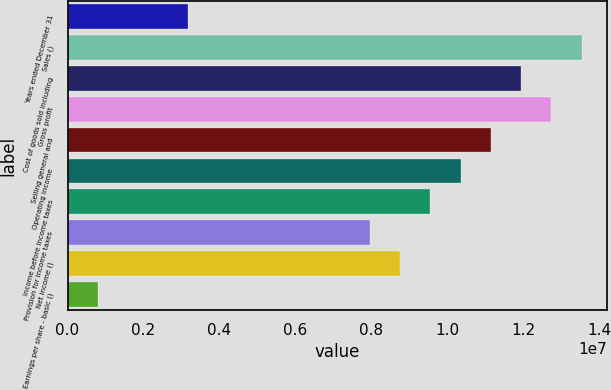Convert chart to OTSL. <chart><loc_0><loc_0><loc_500><loc_500><bar_chart><fcel>Years ended December 31<fcel>Sales ()<fcel>Cost of goods sold including<fcel>Gross profit<fcel>Selling general and<fcel>Operating income<fcel>Income before income taxes<fcel>Provision for income taxes<fcel>Net income ()<fcel>Earnings per share - basic ()<nl><fcel>3.18668e+06<fcel>1.35433e+07<fcel>1.195e+07<fcel>1.27467e+07<fcel>1.11533e+07<fcel>1.03567e+07<fcel>9.56001e+06<fcel>7.96667e+06<fcel>8.76334e+06<fcel>796676<nl></chart> 